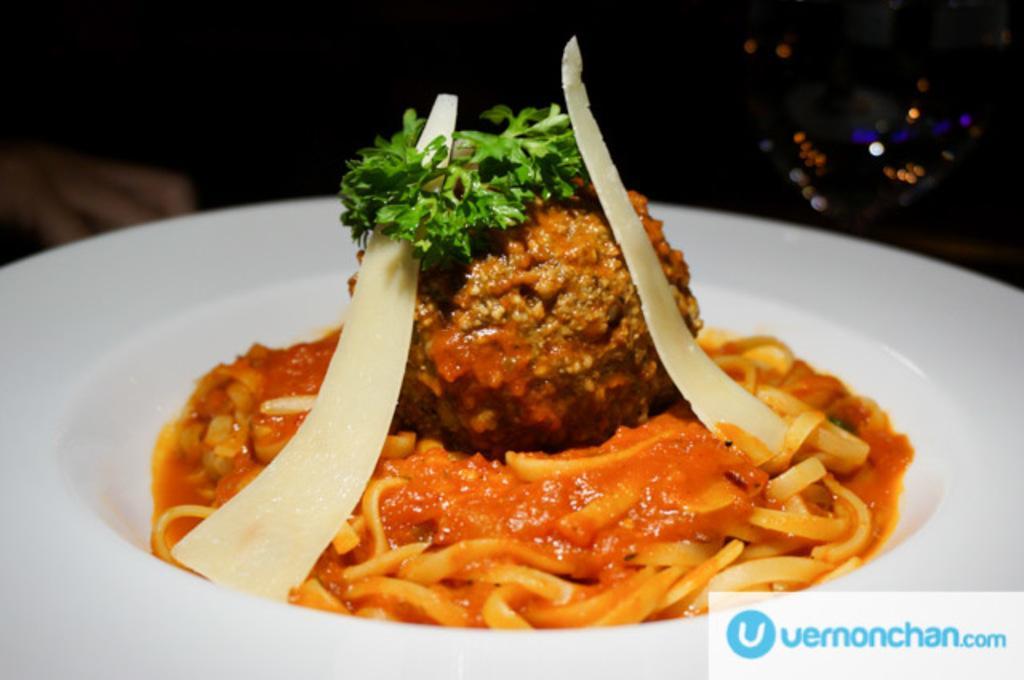How would you summarize this image in a sentence or two? This picture shows food in the plate and we see a logo at the right bottom of the picture. 